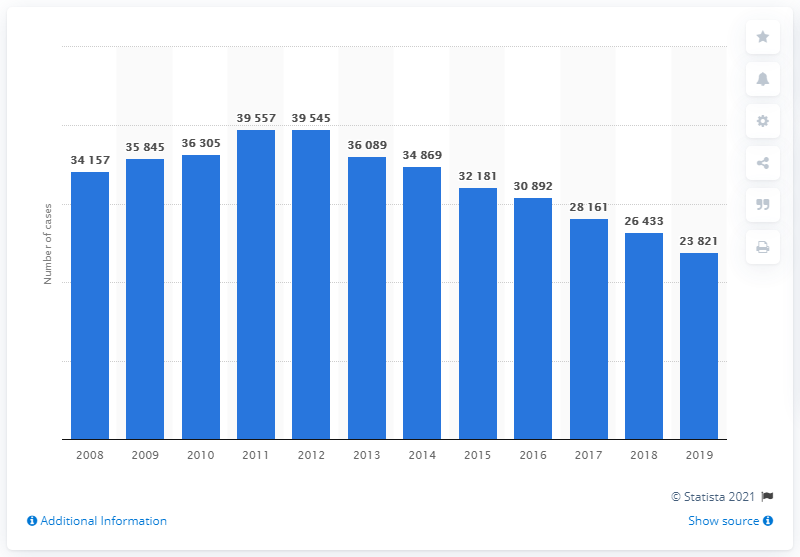Specify some key components in this picture. In 2019, there were a total of 23,821 cases of tuberculosis in South Korea. The number of tuberculosis cases in South Korea during the previous year was 26,433. 